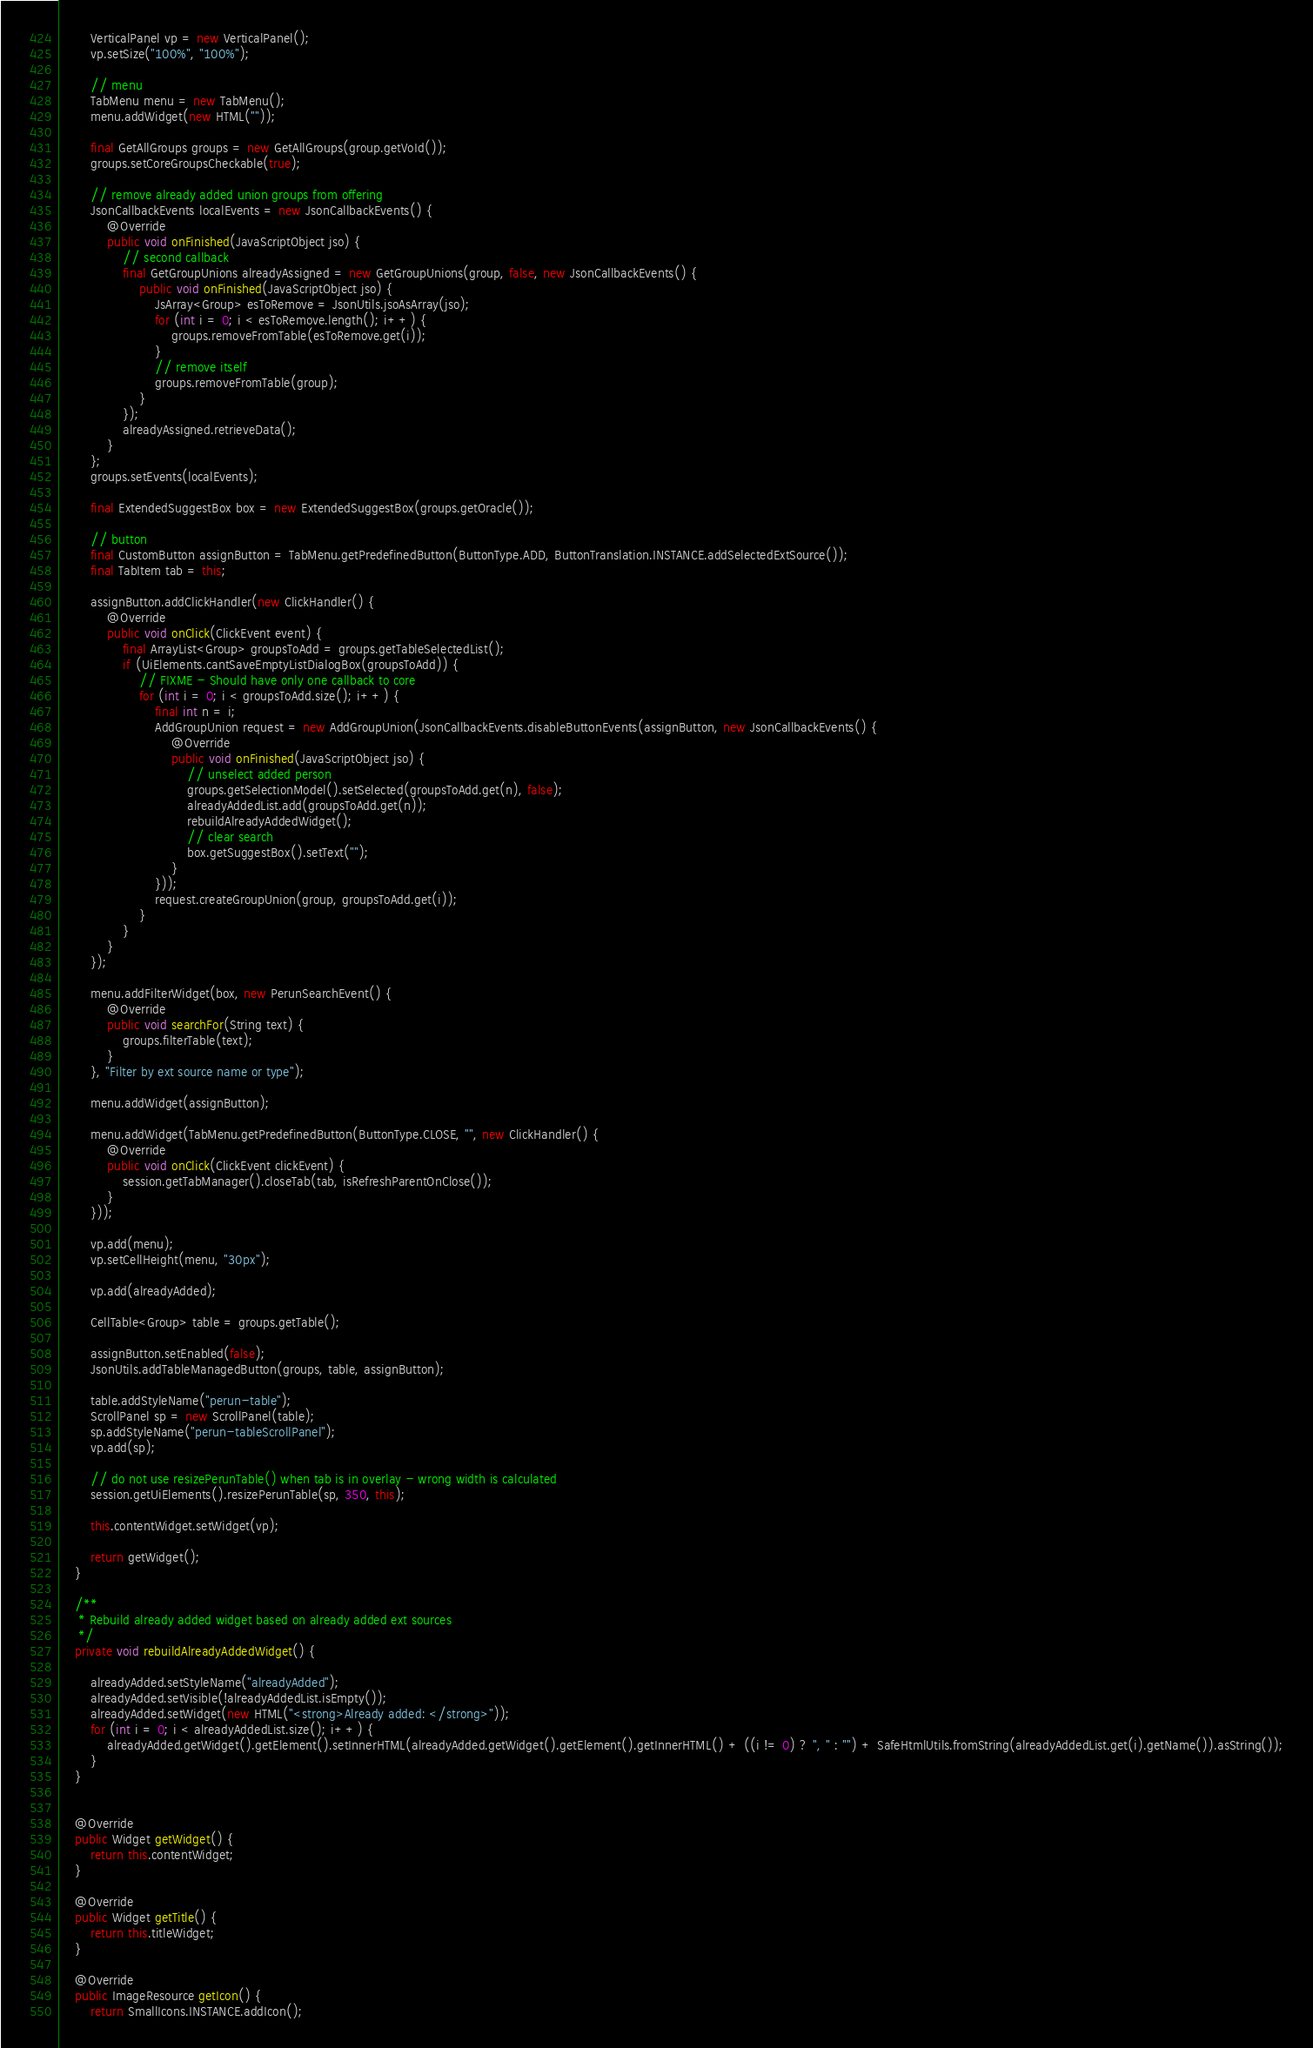<code> <loc_0><loc_0><loc_500><loc_500><_Java_>		VerticalPanel vp = new VerticalPanel();
		vp.setSize("100%", "100%");

		// menu
		TabMenu menu = new TabMenu();
		menu.addWidget(new HTML(""));

		final GetAllGroups groups = new GetAllGroups(group.getVoId());
		groups.setCoreGroupsCheckable(true);

		// remove already added union groups from offering
		JsonCallbackEvents localEvents = new JsonCallbackEvents() {
			@Override
			public void onFinished(JavaScriptObject jso) {
				// second callback
				final GetGroupUnions alreadyAssigned = new GetGroupUnions(group, false, new JsonCallbackEvents() {
					public void onFinished(JavaScriptObject jso) {
						JsArray<Group> esToRemove = JsonUtils.jsoAsArray(jso);
						for (int i = 0; i < esToRemove.length(); i++) {
							groups.removeFromTable(esToRemove.get(i));
						}
						// remove itself
						groups.removeFromTable(group);
					}
				});
				alreadyAssigned.retrieveData();
			}
		};
		groups.setEvents(localEvents);

		final ExtendedSuggestBox box = new ExtendedSuggestBox(groups.getOracle());

		// button
		final CustomButton assignButton = TabMenu.getPredefinedButton(ButtonType.ADD, ButtonTranslation.INSTANCE.addSelectedExtSource());
		final TabItem tab = this;

		assignButton.addClickHandler(new ClickHandler() {
			@Override
			public void onClick(ClickEvent event) {
				final ArrayList<Group> groupsToAdd = groups.getTableSelectedList();
				if (UiElements.cantSaveEmptyListDialogBox(groupsToAdd)) {
					// FIXME - Should have only one callback to core
					for (int i = 0; i < groupsToAdd.size(); i++) {
						final int n = i;
						AddGroupUnion request = new AddGroupUnion(JsonCallbackEvents.disableButtonEvents(assignButton, new JsonCallbackEvents() {
							@Override
							public void onFinished(JavaScriptObject jso) {
								// unselect added person
								groups.getSelectionModel().setSelected(groupsToAdd.get(n), false);
								alreadyAddedList.add(groupsToAdd.get(n));
								rebuildAlreadyAddedWidget();
								// clear search
								box.getSuggestBox().setText("");
							}
						}));
						request.createGroupUnion(group, groupsToAdd.get(i));
					}
				}
			}
		});

		menu.addFilterWidget(box, new PerunSearchEvent() {
			@Override
			public void searchFor(String text) {
				groups.filterTable(text);
			}
		}, "Filter by ext source name or type");

		menu.addWidget(assignButton);

		menu.addWidget(TabMenu.getPredefinedButton(ButtonType.CLOSE, "", new ClickHandler() {
			@Override
			public void onClick(ClickEvent clickEvent) {
				session.getTabManager().closeTab(tab, isRefreshParentOnClose());
			}
		}));

		vp.add(menu);
		vp.setCellHeight(menu, "30px");

		vp.add(alreadyAdded);

		CellTable<Group> table = groups.getTable();

		assignButton.setEnabled(false);
		JsonUtils.addTableManagedButton(groups, table, assignButton);

		table.addStyleName("perun-table");
		ScrollPanel sp = new ScrollPanel(table);
		sp.addStyleName("perun-tableScrollPanel");
		vp.add(sp);

		// do not use resizePerunTable() when tab is in overlay - wrong width is calculated
		session.getUiElements().resizePerunTable(sp, 350, this);

		this.contentWidget.setWidget(vp);

		return getWidget();
	}

	/**
	 * Rebuild already added widget based on already added ext sources
	 */
	private void rebuildAlreadyAddedWidget() {

		alreadyAdded.setStyleName("alreadyAdded");
		alreadyAdded.setVisible(!alreadyAddedList.isEmpty());
		alreadyAdded.setWidget(new HTML("<strong>Already added: </strong>"));
		for (int i = 0; i < alreadyAddedList.size(); i++) {
			alreadyAdded.getWidget().getElement().setInnerHTML(alreadyAdded.getWidget().getElement().getInnerHTML() + ((i != 0) ? ", " : "") + SafeHtmlUtils.fromString(alreadyAddedList.get(i).getName()).asString());
		}
	}


	@Override
	public Widget getWidget() {
		return this.contentWidget;
	}

	@Override
	public Widget getTitle() {
		return this.titleWidget;
	}

	@Override
	public ImageResource getIcon() {
		return SmallIcons.INSTANCE.addIcon();</code> 